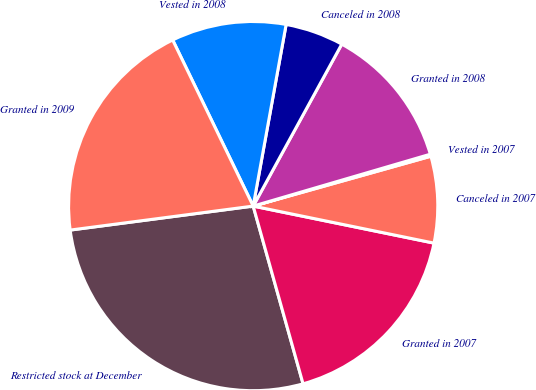Convert chart to OTSL. <chart><loc_0><loc_0><loc_500><loc_500><pie_chart><fcel>Restricted stock at December<fcel>Granted in 2007<fcel>Canceled in 2007<fcel>Vested in 2007<fcel>Granted in 2008<fcel>Canceled in 2008<fcel>Vested in 2008<fcel>Granted in 2009<nl><fcel>27.28%<fcel>17.43%<fcel>7.57%<fcel>0.18%<fcel>12.5%<fcel>5.11%<fcel>10.04%<fcel>19.89%<nl></chart> 